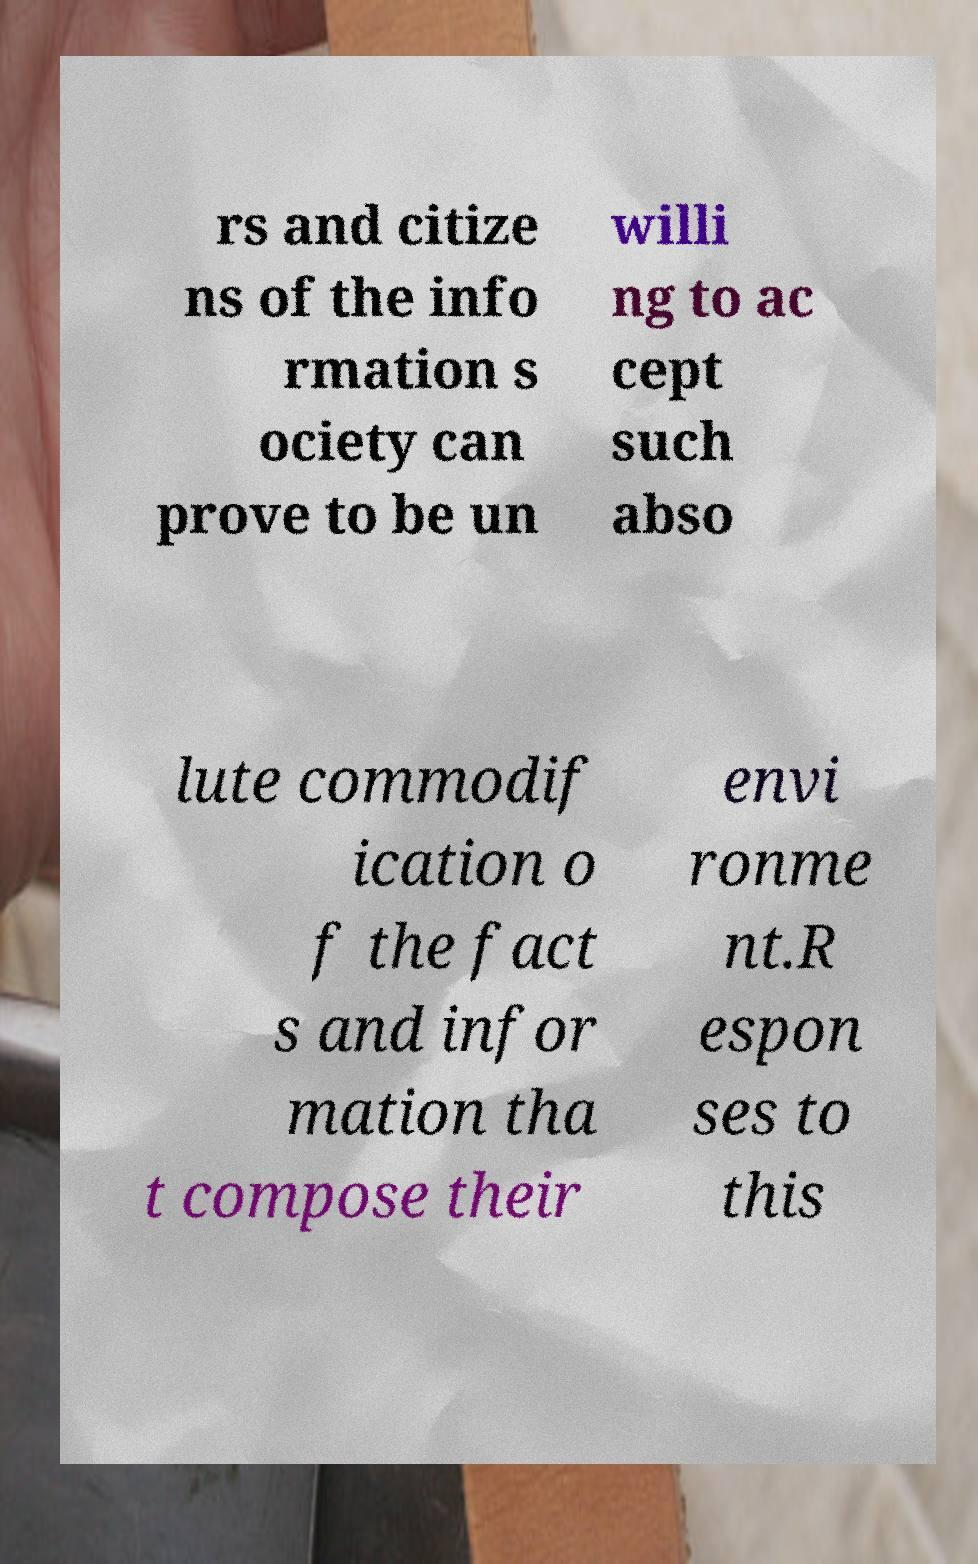I need the written content from this picture converted into text. Can you do that? rs and citize ns of the info rmation s ociety can prove to be un willi ng to ac cept such abso lute commodif ication o f the fact s and infor mation tha t compose their envi ronme nt.R espon ses to this 